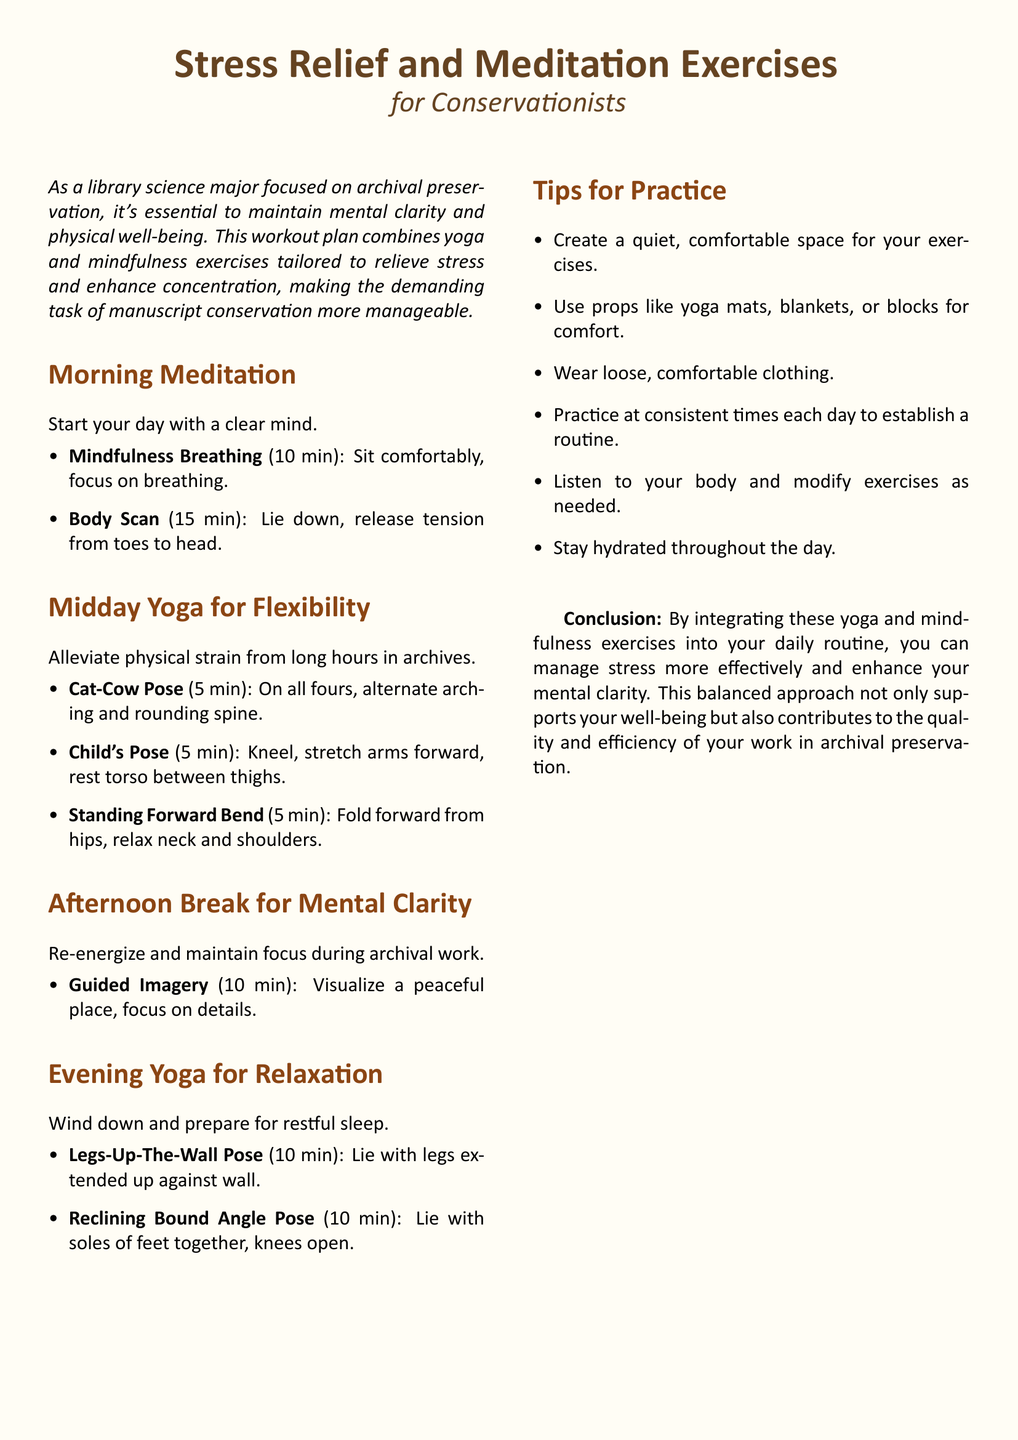What is the main purpose of the workout plan? The workout plan aims to relieve stress and enhance concentration for conservationists.
Answer: Relieve stress and enhance concentration How long is the Mindfulness Breathing exercise? The document states that the Mindfulness Breathing exercise lasts for 10 minutes.
Answer: 10 min What pose is suggested for flexibility during midday? The Cat-Cow Pose is included as a midday yoga exercise for flexibility.
Answer: Cat-Cow Pose How many minutes is allocated for the Guided Imagery exercise? The Guided Imagery exercise is set for 10 minutes in the afternoon break.
Answer: 10 min What should practitioners do if they need to modify exercises? Practitioners are advised to listen to their body and modify exercises as needed.
Answer: Listen to your body Which yoga pose helps in relaxation before sleep? The Legs-Up-The-Wall Pose is recommended for relaxation in the evening.
Answer: Legs-Up-The-Wall Pose What type of clothing is recommended for practice? The document suggests wearing loose, comfortable clothing for practicing yoga and mindfulness.
Answer: Loose, comfortable clothing How can you create a conducive environment for your exercises? To create a suitable environment, one should establish a quiet, comfortable space.
Answer: Quiet, comfortable space 